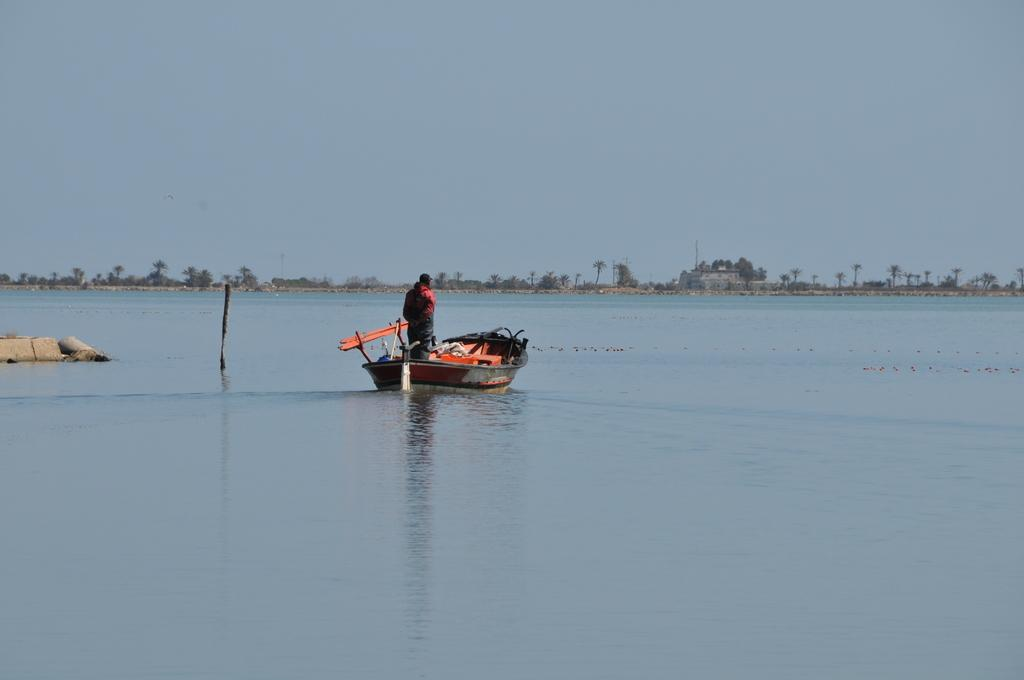What is the person in the image doing? The person is standing on a boat in the image. What is the primary setting of the image? There is water visible in the image. What type of vegetation can be seen in the image? There are trees in the image. What type of structures are present in the image? There are buildings in the image. What is visible in the background of the image? The sky is visible in the image. How many units of crush can be seen in the image? There is no mention of "crush" or any related objects in the image, so it is not possible to answer this question. 